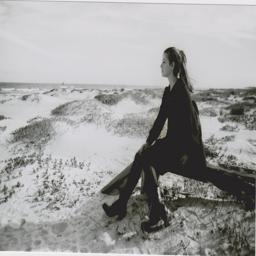Your task involves analyzing an image of a scene and identifying the appropriate name for that particular scene. The scene captured in the image represents a tranquil, natural environment best described as 'dunes' or more specifically 'coastal dunes' if nearby water is implied. The rolling sand hills and sparsely distributed vegetation typically characterize such landscapes. An analysis of the vegetation types, such as the presence of sea oats or other dune-specific plants, could further confirm the coastal context, enriching the scene's description. 